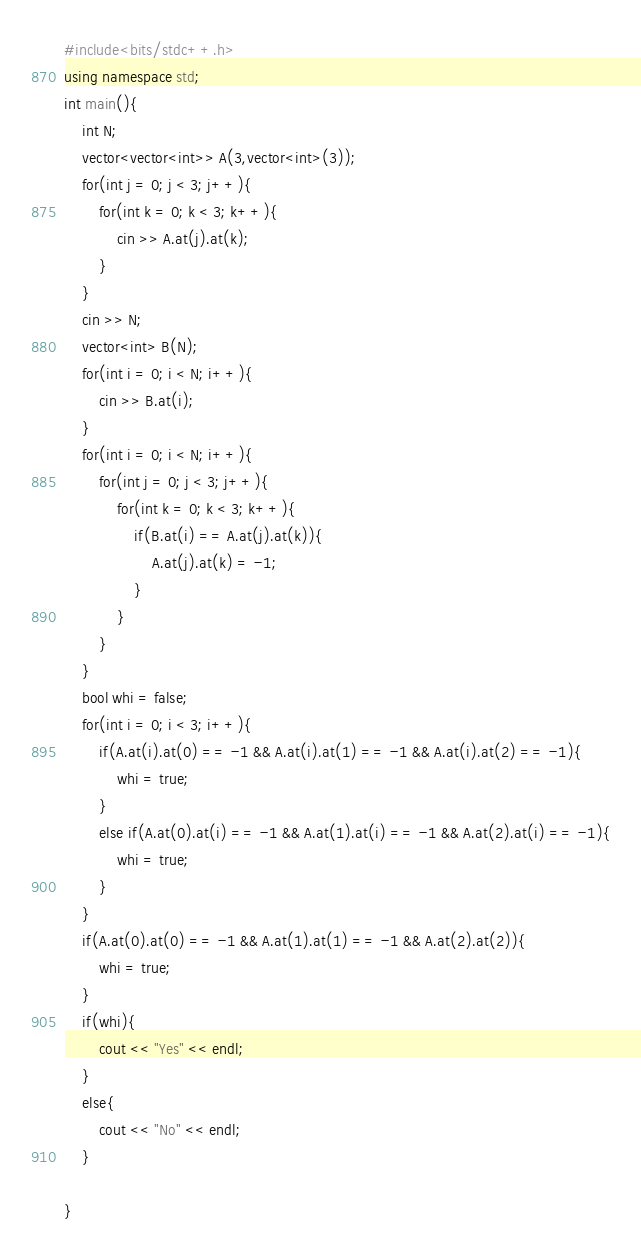Convert code to text. <code><loc_0><loc_0><loc_500><loc_500><_C++_>#include<bits/stdc++.h>
using namespace std;
int main(){
    int N;
    vector<vector<int>> A(3,vector<int>(3));
    for(int j = 0; j < 3; j++){
        for(int k = 0; k < 3; k++){
            cin >> A.at(j).at(k);
        }
    }
    cin >> N;
    vector<int> B(N);
    for(int i = 0; i < N; i++){
        cin >> B.at(i);
    }
    for(int i = 0; i < N; i++){
        for(int j = 0; j < 3; j++){
            for(int k = 0; k < 3; k++){
                if(B.at(i) == A.at(j).at(k)){
                    A.at(j).at(k) = -1;
                }
            }
        }
    }
    bool whi = false;
    for(int i = 0; i < 3; i++){
        if(A.at(i).at(0) == -1 && A.at(i).at(1) == -1 && A.at(i).at(2) == -1){
            whi = true;
        }
        else if(A.at(0).at(i) == -1 && A.at(1).at(i) == -1 && A.at(2).at(i) == -1){
            whi = true;
        }
    }
    if(A.at(0).at(0) == -1 && A.at(1).at(1) == -1 && A.at(2).at(2)){
        whi = true; 
    }
    if(whi){
        cout << "Yes" << endl;
    }
    else{
        cout << "No" << endl;
    }

}</code> 